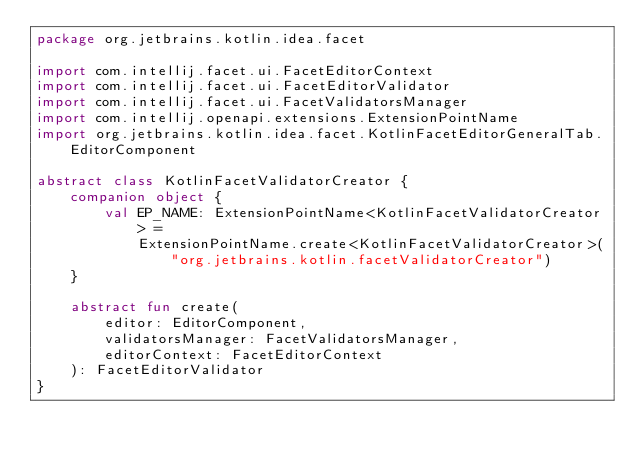Convert code to text. <code><loc_0><loc_0><loc_500><loc_500><_Kotlin_>package org.jetbrains.kotlin.idea.facet

import com.intellij.facet.ui.FacetEditorContext
import com.intellij.facet.ui.FacetEditorValidator
import com.intellij.facet.ui.FacetValidatorsManager
import com.intellij.openapi.extensions.ExtensionPointName
import org.jetbrains.kotlin.idea.facet.KotlinFacetEditorGeneralTab.EditorComponent

abstract class KotlinFacetValidatorCreator {
    companion object {
        val EP_NAME: ExtensionPointName<KotlinFacetValidatorCreator> =
            ExtensionPointName.create<KotlinFacetValidatorCreator>("org.jetbrains.kotlin.facetValidatorCreator")
    }

    abstract fun create(
        editor: EditorComponent,
        validatorsManager: FacetValidatorsManager,
        editorContext: FacetEditorContext
    ): FacetEditorValidator
}</code> 